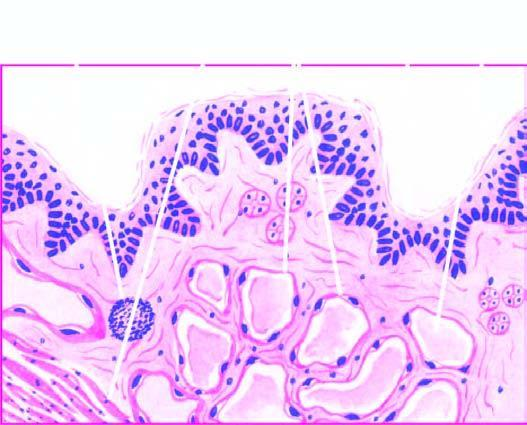re large cystic spaces lined by the flattened endothelial cells and containing lymph present?
Answer the question using a single word or phrase. Yes 